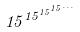Convert formula to latex. <formula><loc_0><loc_0><loc_500><loc_500>1 5 ^ { 1 5 ^ { 1 5 ^ { 1 5 ^ { \dots } } } }</formula> 